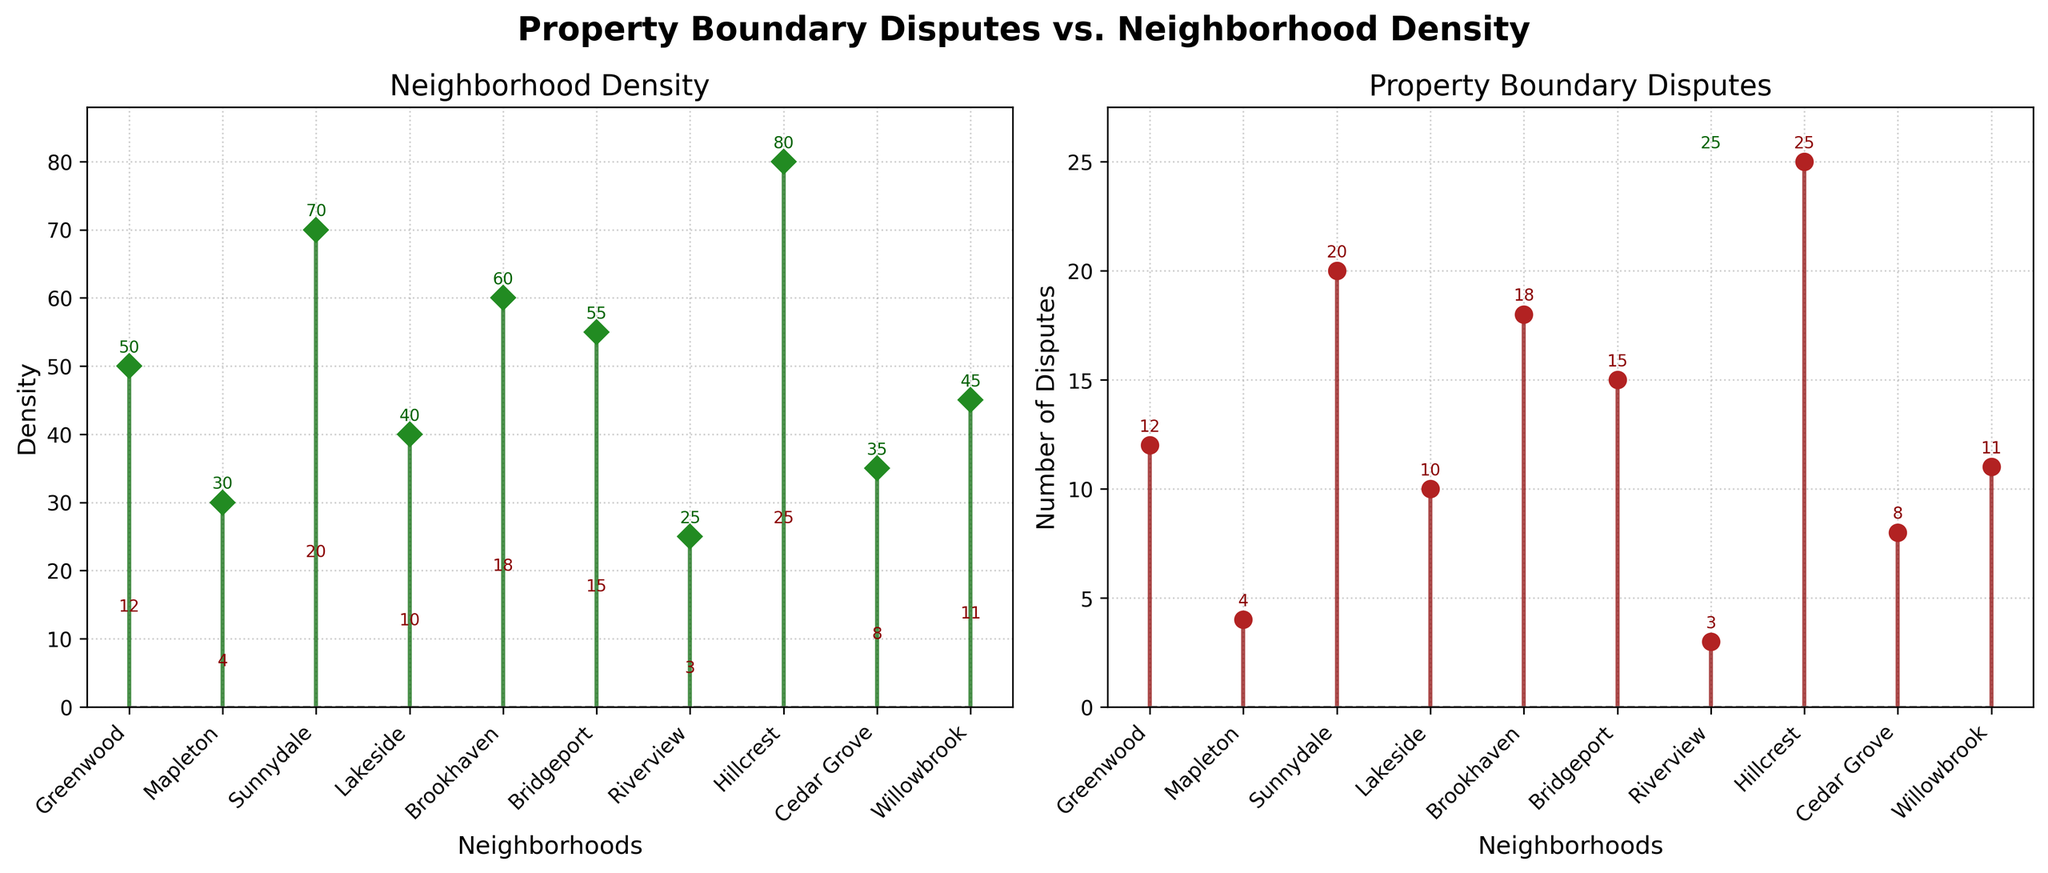What is the title of the figure? The title of the figure is positioned above the subplots and reads "Property Boundary Disputes vs. Neighborhood Density".
Answer: Property Boundary Disputes vs. Neighborhood Density What color are the markers used for Density in the figure? The markers for Density in the figure are green and diamond-shaped.
Answer: Dark green Which neighborhood has the highest density? Observe the stem plot for Neighborhood Density. Hillcrest has the tallest stem, indicating the highest density value.
Answer: Hillcrest How many disputes does Cedar Grove have? Look at the stem plot for Property Boundary Disputes. Identify Cedar Grove on the x-axis and trace upwards to see the marker. The number next to it indicates the number of disputes.
Answer: Eight What is the average density of the neighborhoods? Add all the density values: (50 + 30 + 70 + 40 + 60 + 55 + 25 + 80 + 35 + 45) = 490. Divide by the number of neighborhoods, which is 10. Thus, the average density is 490 / 10.
Answer: 49 Which neighborhood has more disputes, Greenwood or Sunnydale? Compare the heights of the markers for Greenwood and Sunnydale in the Disputes subplot. Sunnydale has a higher marker, indicating more disputes.
Answer: Sunnydale What is the difference in density between the least dense neighborhood and the most dense neighborhood? The least dense neighborhood is Riverview with a density of 25. The most dense is Hillcrest with a density of 80. Subtract the two: 80 - 25 = 55.
Answer: 55 Which neighborhood has the closest number of disputes to the average number of disputes? First, calculate the average number of disputes: (12 + 4 + 20 + 10 + 18 + 15 + 3 + 25 + 8 + 11) = 126. Divide by 10 (total neighborhoods) to get 12.6. Greenwood, with 12 disputes, is closest to the average.
Answer: Greenwood Are there more neighborhoods with density above 50 or below 50? Count the number of neighborhoods above 50 (Sunnydale, Brookhaven, Bridgeport, Hillcrest) and below 50 (Mapleton, Riverview, Cedar Grove, Willowbrook, Lakeside). There are 4 above and 5 below.
Answer: Below 50 Is there a visible trend between density and disputes in neighborhoods? Examine both stem plots side by side. In general, neighborhoods with higher density like Hillcrest and Sunnydale also have more disputes, suggesting a positive correlation.
Answer: Yes, there is a positive correlation 